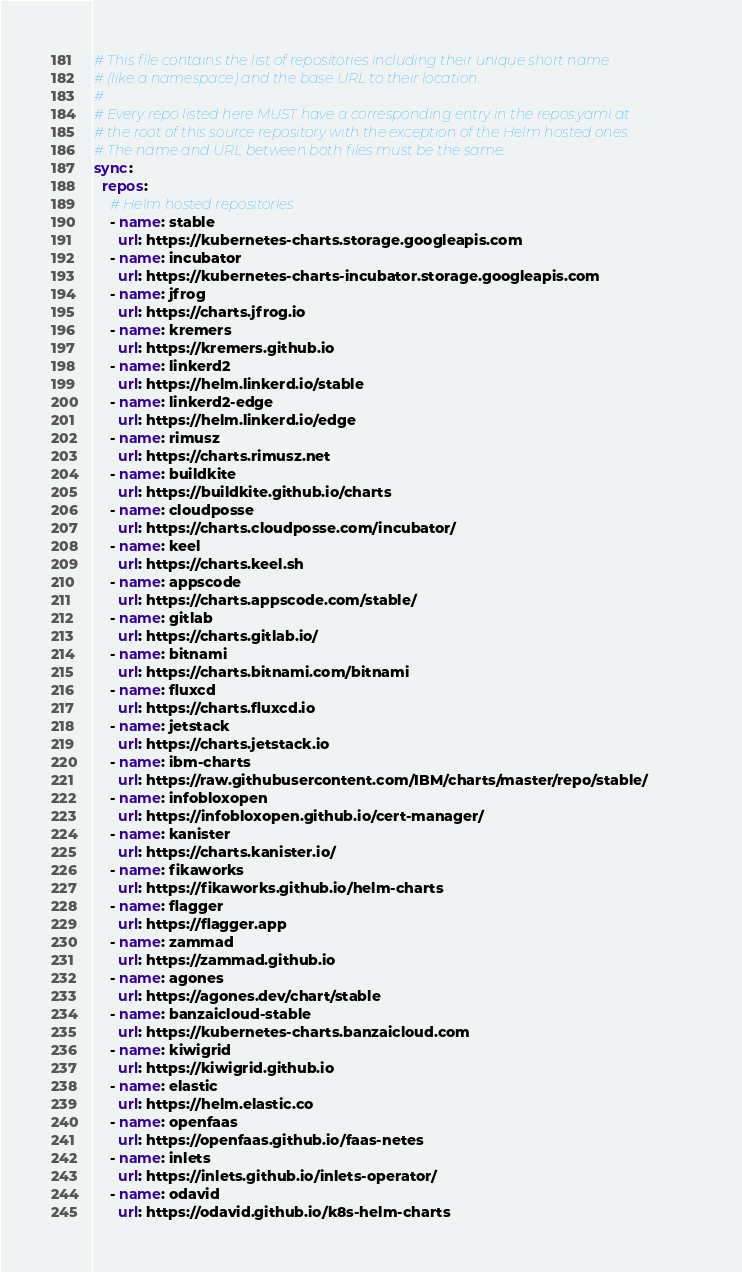Convert code to text. <code><loc_0><loc_0><loc_500><loc_500><_YAML_># This file contains the list of repositories including their unique short name
# (like a namespace) and the base URL to their location.
#
# Every repo listed here MUST have a corresponding entry in the repos.yaml at
# the root of this source repository with the exception of the Helm hosted ones.
# The name and URL between both files must be the same.
sync:
  repos:
    # Helm hosted repositories
    - name: stable
      url: https://kubernetes-charts.storage.googleapis.com
    - name: incubator
      url: https://kubernetes-charts-incubator.storage.googleapis.com
    - name: jfrog
      url: https://charts.jfrog.io
    - name: kremers
      url: https://kremers.github.io
    - name: linkerd2
      url: https://helm.linkerd.io/stable
    - name: linkerd2-edge
      url: https://helm.linkerd.io/edge
    - name: rimusz
      url: https://charts.rimusz.net
    - name: buildkite
      url: https://buildkite.github.io/charts
    - name: cloudposse
      url: https://charts.cloudposse.com/incubator/
    - name: keel
      url: https://charts.keel.sh
    - name: appscode
      url: https://charts.appscode.com/stable/
    - name: gitlab
      url: https://charts.gitlab.io/
    - name: bitnami
      url: https://charts.bitnami.com/bitnami
    - name: fluxcd
      url: https://charts.fluxcd.io
    - name: jetstack
      url: https://charts.jetstack.io
    - name: ibm-charts
      url: https://raw.githubusercontent.com/IBM/charts/master/repo/stable/
    - name: infobloxopen
      url: https://infobloxopen.github.io/cert-manager/
    - name: kanister
      url: https://charts.kanister.io/
    - name: fikaworks
      url: https://fikaworks.github.io/helm-charts
    - name: flagger
      url: https://flagger.app
    - name: zammad
      url: https://zammad.github.io
    - name: agones
      url: https://agones.dev/chart/stable
    - name: banzaicloud-stable
      url: https://kubernetes-charts.banzaicloud.com
    - name: kiwigrid
      url: https://kiwigrid.github.io
    - name: elastic
      url: https://helm.elastic.co
    - name: openfaas
      url: https://openfaas.github.io/faas-netes
    - name: inlets
      url: https://inlets.github.io/inlets-operator/
    - name: odavid
      url: https://odavid.github.io/k8s-helm-charts</code> 